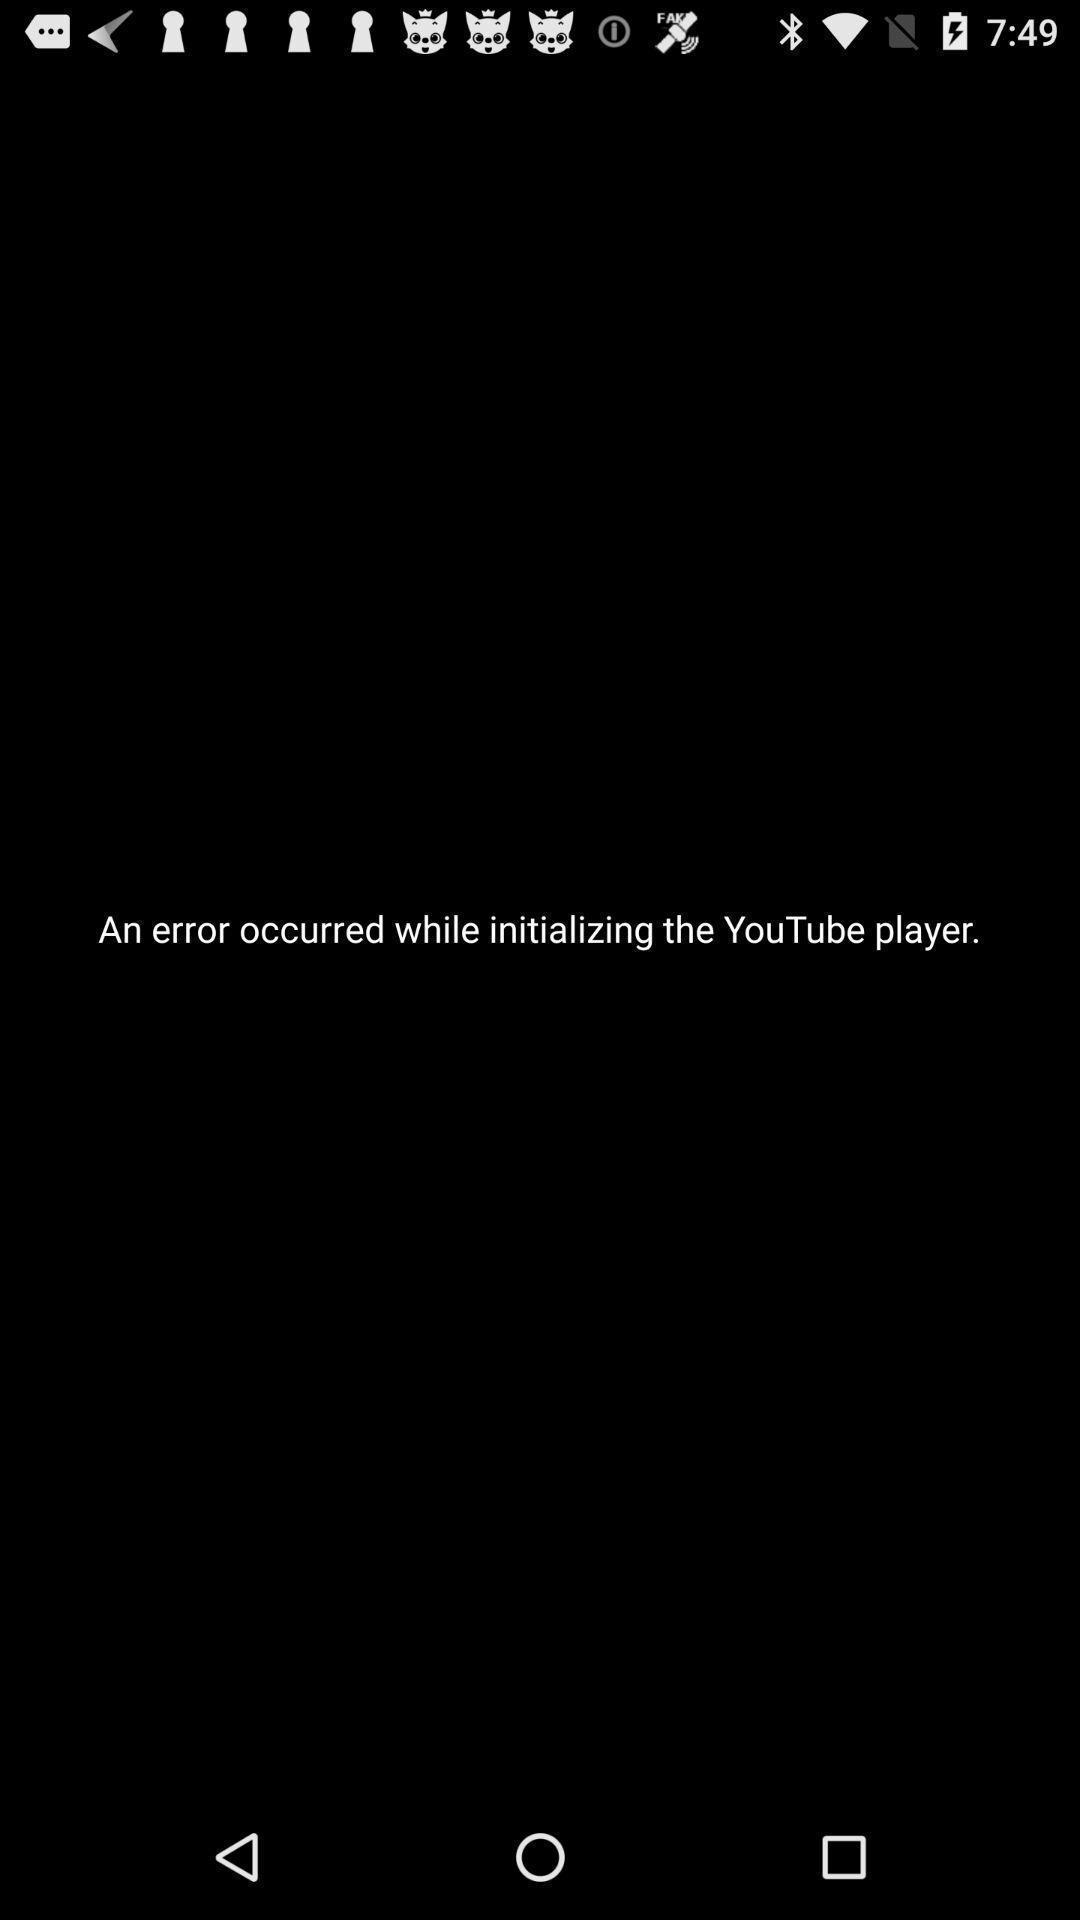Please provide a description for this image. Page that displays an error occurred while initializing social application. 